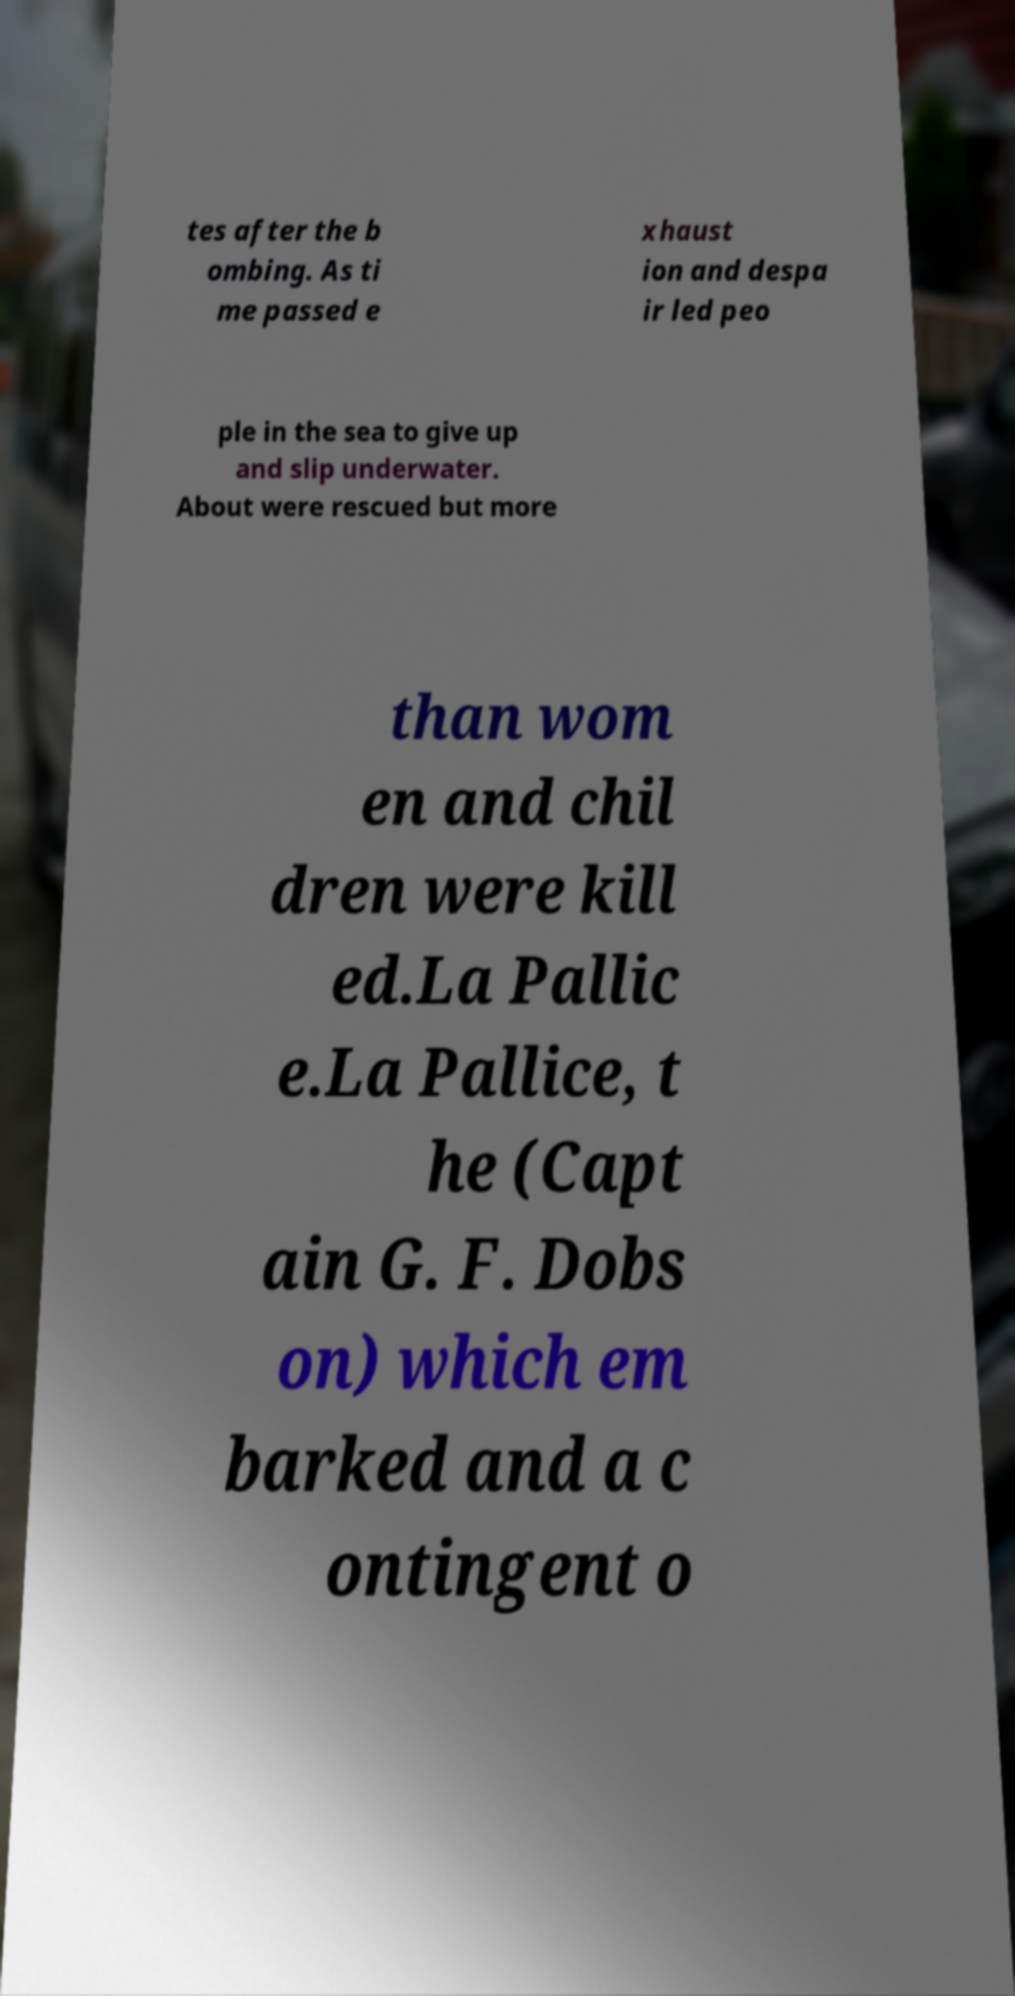For documentation purposes, I need the text within this image transcribed. Could you provide that? tes after the b ombing. As ti me passed e xhaust ion and despa ir led peo ple in the sea to give up and slip underwater. About were rescued but more than wom en and chil dren were kill ed.La Pallic e.La Pallice, t he (Capt ain G. F. Dobs on) which em barked and a c ontingent o 